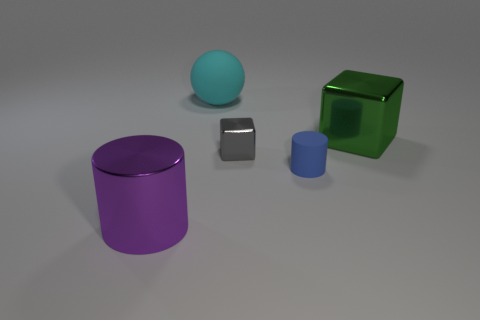Add 5 blue metal cylinders. How many objects exist? 10 Subtract all cubes. How many objects are left? 3 Subtract 1 cubes. How many cubes are left? 1 Subtract all cyan rubber balls. Subtract all big cyan rubber spheres. How many objects are left? 3 Add 5 gray things. How many gray things are left? 6 Add 3 large blue matte objects. How many large blue matte objects exist? 3 Subtract 0 cyan cylinders. How many objects are left? 5 Subtract all green spheres. Subtract all red cubes. How many spheres are left? 1 